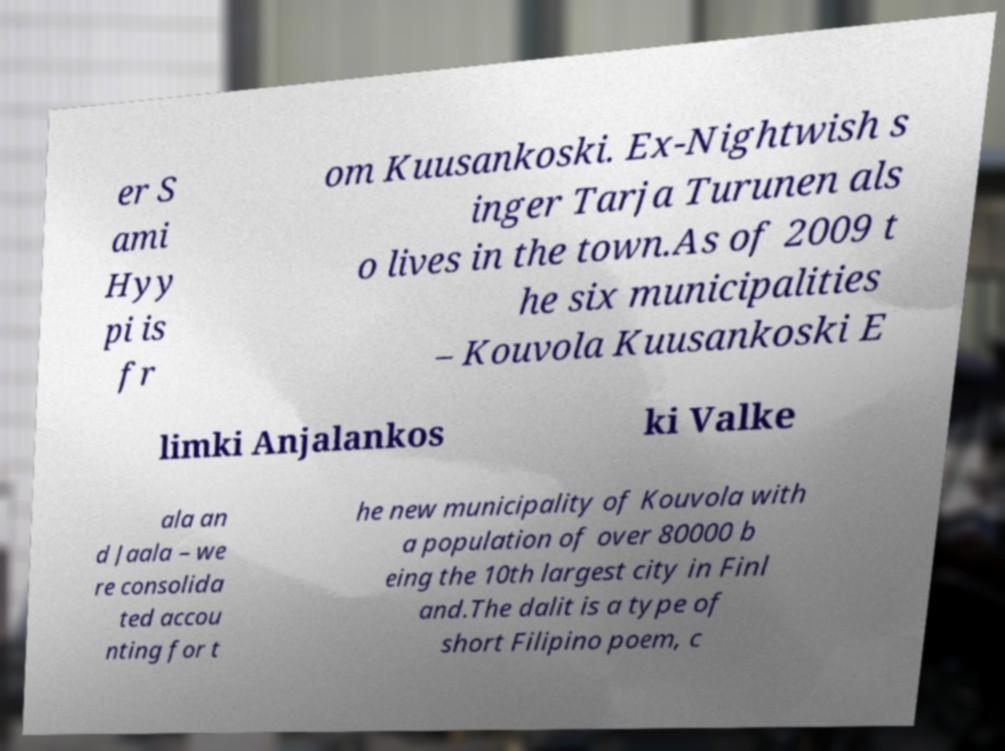There's text embedded in this image that I need extracted. Can you transcribe it verbatim? er S ami Hyy pi is fr om Kuusankoski. Ex-Nightwish s inger Tarja Turunen als o lives in the town.As of 2009 t he six municipalities – Kouvola Kuusankoski E limki Anjalankos ki Valke ala an d Jaala – we re consolida ted accou nting for t he new municipality of Kouvola with a population of over 80000 b eing the 10th largest city in Finl and.The dalit is a type of short Filipino poem, c 